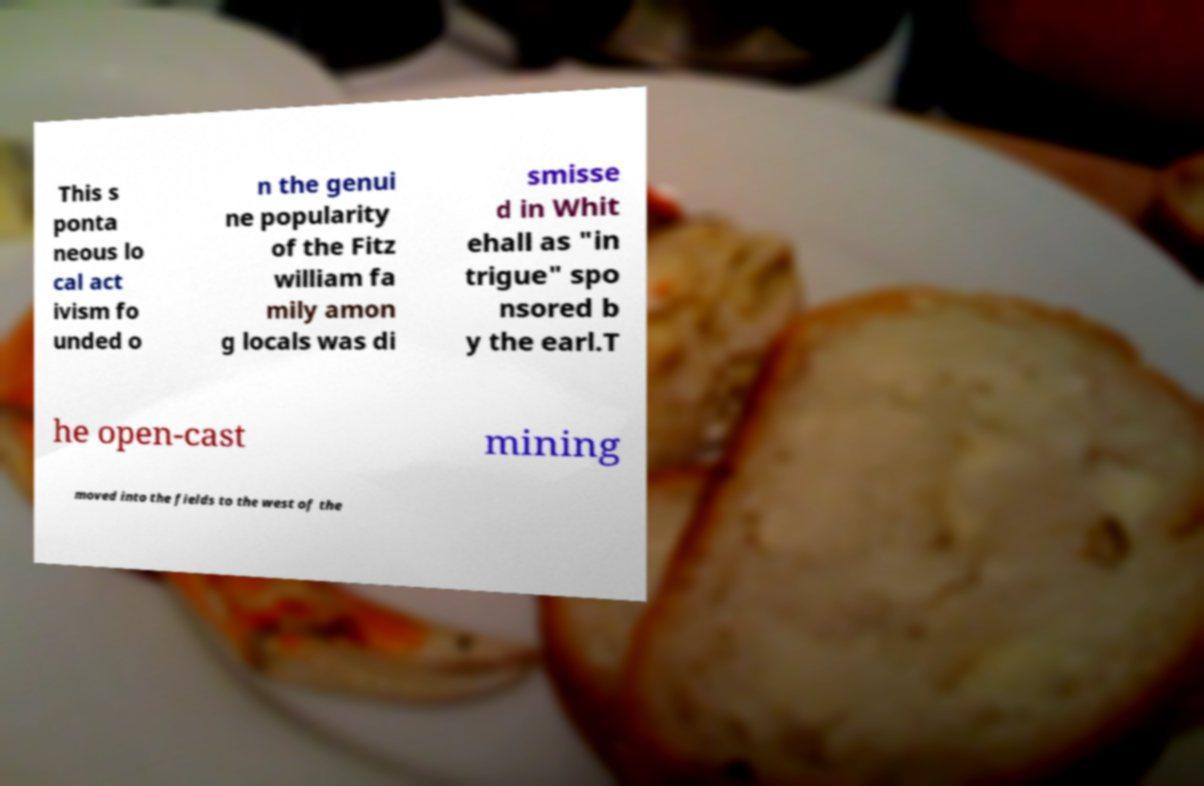Please read and relay the text visible in this image. What does it say? This s ponta neous lo cal act ivism fo unded o n the genui ne popularity of the Fitz william fa mily amon g locals was di smisse d in Whit ehall as "in trigue" spo nsored b y the earl.T he open-cast mining moved into the fields to the west of the 